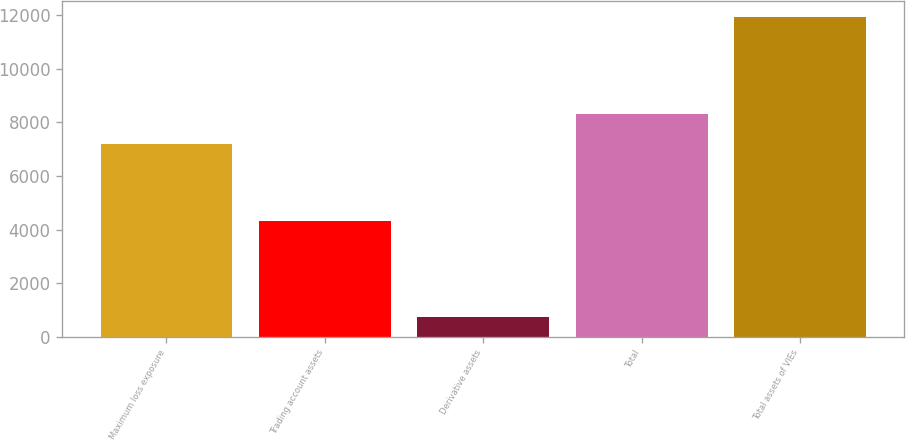Convert chart to OTSL. <chart><loc_0><loc_0><loc_500><loc_500><bar_chart><fcel>Maximum loss exposure<fcel>Trading account assets<fcel>Derivative assets<fcel>Total<fcel>Total assets of VIEs<nl><fcel>7184<fcel>4334<fcel>723<fcel>8305.4<fcel>11937<nl></chart> 